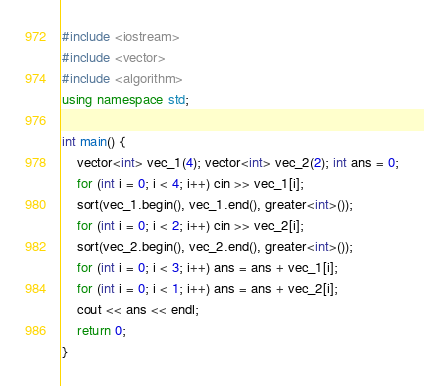<code> <loc_0><loc_0><loc_500><loc_500><_C++_>#include <iostream>
#include <vector>
#include <algorithm>
using namespace std;

int main() {
	vector<int> vec_1(4); vector<int> vec_2(2); int ans = 0;
	for (int i = 0; i < 4; i++) cin >> vec_1[i];
	sort(vec_1.begin(), vec_1.end(), greater<int>());
	for (int i = 0; i < 2; i++) cin >> vec_2[i];
	sort(vec_2.begin(), vec_2.end(), greater<int>());
	for (int i = 0; i < 3; i++) ans = ans + vec_1[i];
	for (int i = 0; i < 1; i++) ans = ans + vec_2[i];
	cout << ans << endl;
	return 0;
}
</code> 